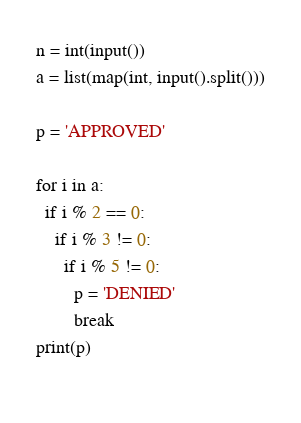Convert code to text. <code><loc_0><loc_0><loc_500><loc_500><_Python_>n = int(input())
a = list(map(int, input().split()))

p = 'APPROVED'

for i in a:
  if i % 2 == 0:
    if i % 3 != 0:
      if i % 5 != 0:
        p = 'DENIED'
        break
print(p)
      </code> 